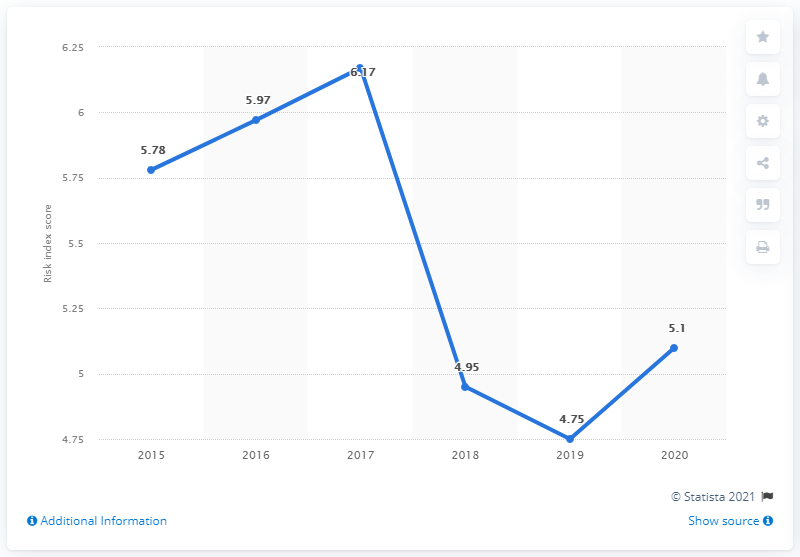Mention a couple of crucial points in this snapshot. In 2017, Guatemala was ranked the highest in the money laundering and terrorism financing risk index, reflecting its poor performance in addressing these issues. According to the 2020 money laundering and terrorism financing risk index for Guatemala, the country received a score of 5.1, indicating a moderate level of risk. 